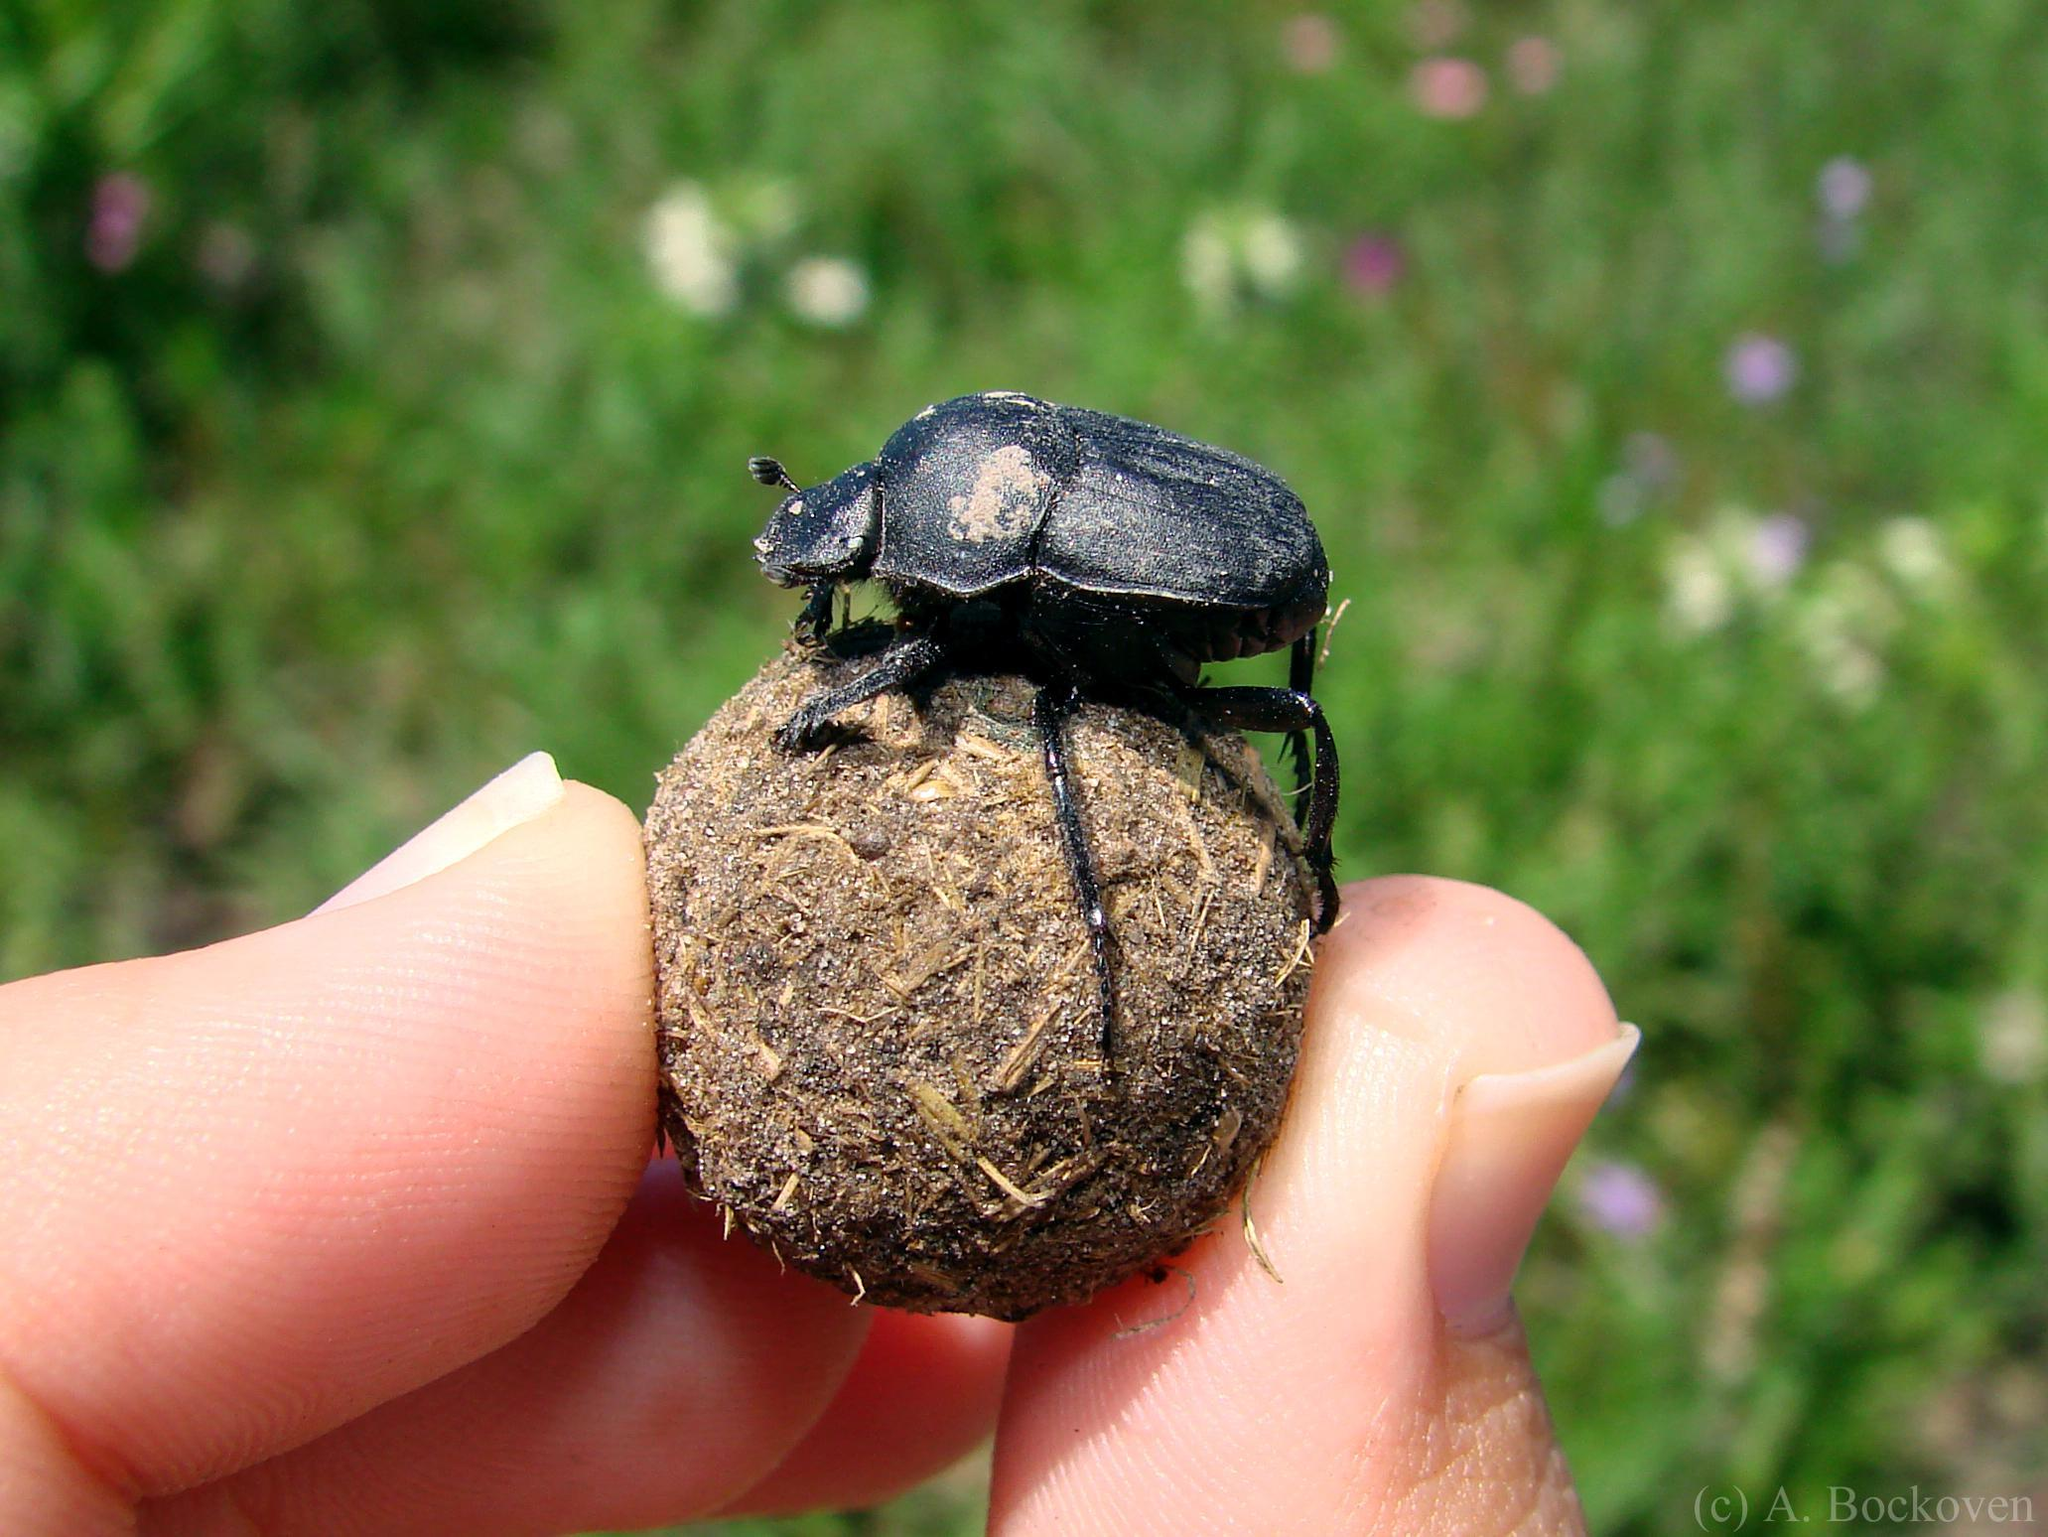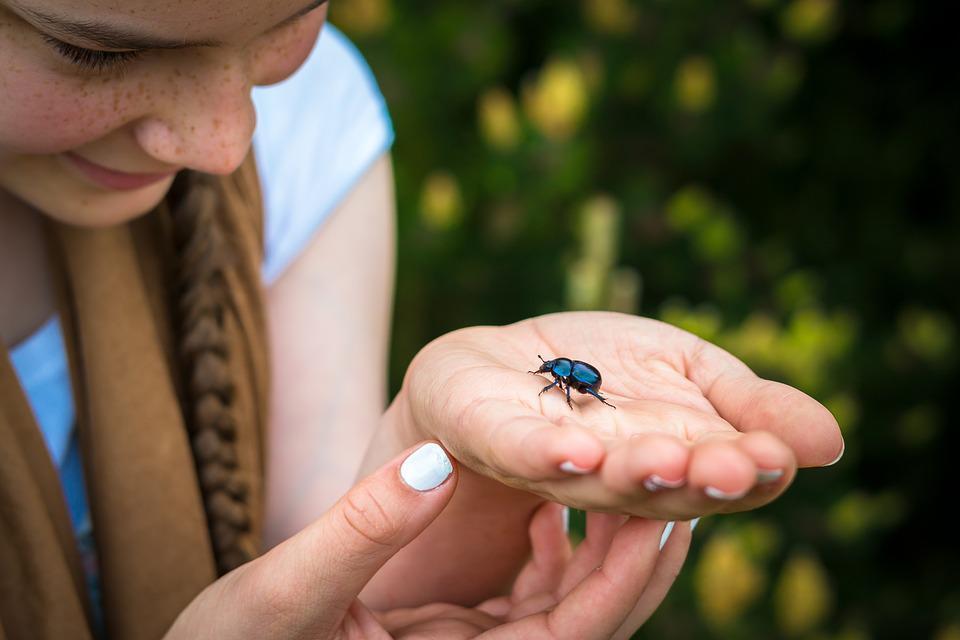The first image is the image on the left, the second image is the image on the right. Evaluate the accuracy of this statement regarding the images: "The right image has a beetle crawling on a persons hand.". Is it true? Answer yes or no. Yes. The first image is the image on the left, the second image is the image on the right. For the images displayed, is the sentence "A beetle crawls on a persons hand in the image on the right." factually correct? Answer yes or no. Yes. 